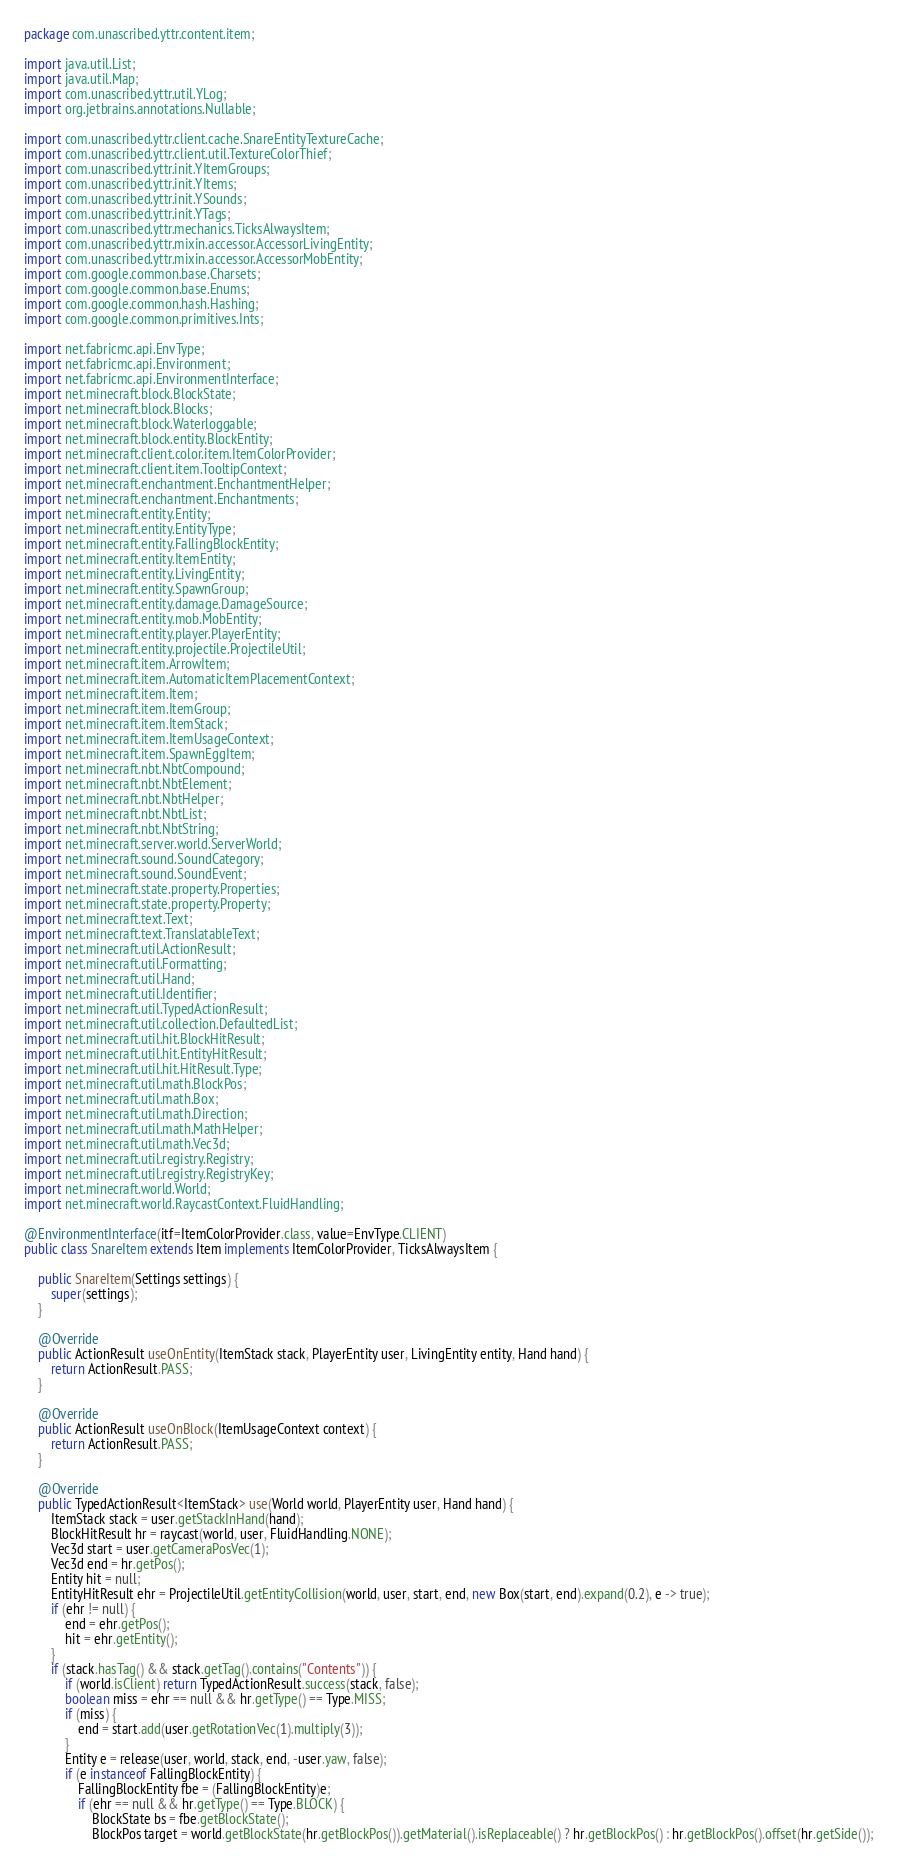Convert code to text. <code><loc_0><loc_0><loc_500><loc_500><_Java_>package com.unascribed.yttr.content.item;

import java.util.List;
import java.util.Map;
import com.unascribed.yttr.util.YLog;
import org.jetbrains.annotations.Nullable;

import com.unascribed.yttr.client.cache.SnareEntityTextureCache;
import com.unascribed.yttr.client.util.TextureColorThief;
import com.unascribed.yttr.init.YItemGroups;
import com.unascribed.yttr.init.YItems;
import com.unascribed.yttr.init.YSounds;
import com.unascribed.yttr.init.YTags;
import com.unascribed.yttr.mechanics.TicksAlwaysItem;
import com.unascribed.yttr.mixin.accessor.AccessorLivingEntity;
import com.unascribed.yttr.mixin.accessor.AccessorMobEntity;
import com.google.common.base.Charsets;
import com.google.common.base.Enums;
import com.google.common.hash.Hashing;
import com.google.common.primitives.Ints;

import net.fabricmc.api.EnvType;
import net.fabricmc.api.Environment;
import net.fabricmc.api.EnvironmentInterface;
import net.minecraft.block.BlockState;
import net.minecraft.block.Blocks;
import net.minecraft.block.Waterloggable;
import net.minecraft.block.entity.BlockEntity;
import net.minecraft.client.color.item.ItemColorProvider;
import net.minecraft.client.item.TooltipContext;
import net.minecraft.enchantment.EnchantmentHelper;
import net.minecraft.enchantment.Enchantments;
import net.minecraft.entity.Entity;
import net.minecraft.entity.EntityType;
import net.minecraft.entity.FallingBlockEntity;
import net.minecraft.entity.ItemEntity;
import net.minecraft.entity.LivingEntity;
import net.minecraft.entity.SpawnGroup;
import net.minecraft.entity.damage.DamageSource;
import net.minecraft.entity.mob.MobEntity;
import net.minecraft.entity.player.PlayerEntity;
import net.minecraft.entity.projectile.ProjectileUtil;
import net.minecraft.item.ArrowItem;
import net.minecraft.item.AutomaticItemPlacementContext;
import net.minecraft.item.Item;
import net.minecraft.item.ItemGroup;
import net.minecraft.item.ItemStack;
import net.minecraft.item.ItemUsageContext;
import net.minecraft.item.SpawnEggItem;
import net.minecraft.nbt.NbtCompound;
import net.minecraft.nbt.NbtElement;
import net.minecraft.nbt.NbtHelper;
import net.minecraft.nbt.NbtList;
import net.minecraft.nbt.NbtString;
import net.minecraft.server.world.ServerWorld;
import net.minecraft.sound.SoundCategory;
import net.minecraft.sound.SoundEvent;
import net.minecraft.state.property.Properties;
import net.minecraft.state.property.Property;
import net.minecraft.text.Text;
import net.minecraft.text.TranslatableText;
import net.minecraft.util.ActionResult;
import net.minecraft.util.Formatting;
import net.minecraft.util.Hand;
import net.minecraft.util.Identifier;
import net.minecraft.util.TypedActionResult;
import net.minecraft.util.collection.DefaultedList;
import net.minecraft.util.hit.BlockHitResult;
import net.minecraft.util.hit.EntityHitResult;
import net.minecraft.util.hit.HitResult.Type;
import net.minecraft.util.math.BlockPos;
import net.minecraft.util.math.Box;
import net.minecraft.util.math.Direction;
import net.minecraft.util.math.MathHelper;
import net.minecraft.util.math.Vec3d;
import net.minecraft.util.registry.Registry;
import net.minecraft.util.registry.RegistryKey;
import net.minecraft.world.World;
import net.minecraft.world.RaycastContext.FluidHandling;

@EnvironmentInterface(itf=ItemColorProvider.class, value=EnvType.CLIENT)
public class SnareItem extends Item implements ItemColorProvider, TicksAlwaysItem {

	public SnareItem(Settings settings) {
		super(settings);
	}
	
	@Override
	public ActionResult useOnEntity(ItemStack stack, PlayerEntity user, LivingEntity entity, Hand hand) {
		return ActionResult.PASS;
	}
	
	@Override
	public ActionResult useOnBlock(ItemUsageContext context) {
		return ActionResult.PASS;
	}
	
	@Override
	public TypedActionResult<ItemStack> use(World world, PlayerEntity user, Hand hand) {
		ItemStack stack = user.getStackInHand(hand);
		BlockHitResult hr = raycast(world, user, FluidHandling.NONE);
		Vec3d start = user.getCameraPosVec(1);
		Vec3d end = hr.getPos();
		Entity hit = null;
		EntityHitResult ehr = ProjectileUtil.getEntityCollision(world, user, start, end, new Box(start, end).expand(0.2), e -> true);
		if (ehr != null) {
			end = ehr.getPos();
			hit = ehr.getEntity();
		}
		if (stack.hasTag() && stack.getTag().contains("Contents")) {
			if (world.isClient) return TypedActionResult.success(stack, false);
			boolean miss = ehr == null && hr.getType() == Type.MISS;
			if (miss) {
				end = start.add(user.getRotationVec(1).multiply(3));
			}
			Entity e = release(user, world, stack, end, -user.yaw, false);
			if (e instanceof FallingBlockEntity) {
				FallingBlockEntity fbe = (FallingBlockEntity)e;
				if (ehr == null && hr.getType() == Type.BLOCK) {
					BlockState bs = fbe.getBlockState();
					BlockPos target = world.getBlockState(hr.getBlockPos()).getMaterial().isReplaceable() ? hr.getBlockPos() : hr.getBlockPos().offset(hr.getSide());</code> 